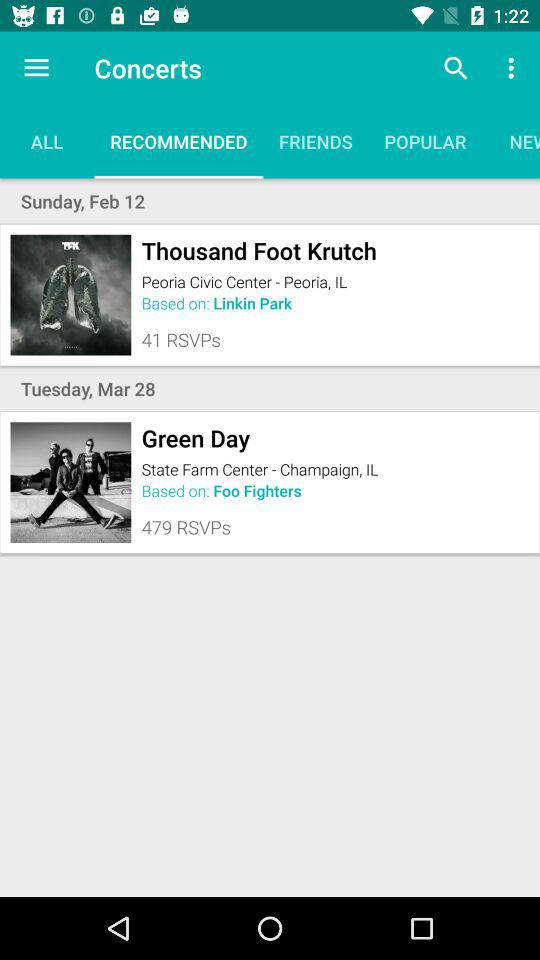How many more RSVPs does Green Day have than Thousand Foot Krutch?
Answer the question using a single word or phrase. 438 